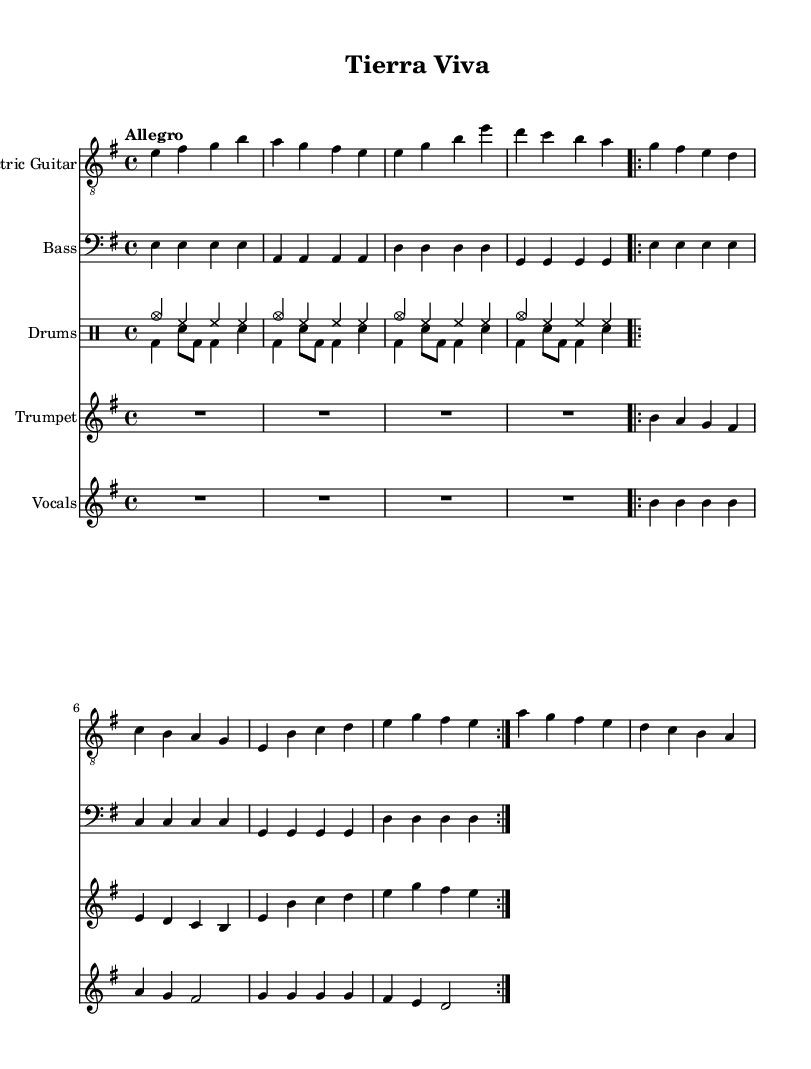What is the key signature of this music? The key signature is E minor, indicated by one sharp (F#) and pertains to the context of the piece. It can be identified at the beginning of the staff where it is stated, showing the notes that fall under E minor.
Answer: E minor What is the time signature used in the music? The time signature is 4/4, as indicated in the score near the beginning. This means there are four beats in each measure, and a quarter note receives one beat.
Answer: 4/4 What tempo marking is given in the piece? The tempo marking is "Allegro," which suggests a fast and lively tempo. This is directly noted at the top of the score and informs the performers about the intended speed of the piece.
Answer: Allegro How many measures does the electric guitar part have? The electric guitar part consists of 8 measures, which can be counted in the notation. Each group of notes separated by vertical lines represents a measure, totaling to eight when carefully counted.
Answer: 8 What instruments are featured in this composition? The composition features electric guitar, bass, drums, trumpet, and vocals. Each instrument has its own labeled staff in the score, making it clear which parts correspond to which instruments.
Answer: Electric guitar, bass, drums, trumpet, vocals How does the vocal melody primarily move through the piece? The vocal melody primarily consists of repetitive patterns and stepwise motion, as seen in the notes and their arrangements in the score. The specific structure and notes show that it generally stays close in range with a few leaps.
Answer: Repetitive patterns What is the theme of the lyrics in this piece? The lyrics convey a theme of environmental consciousness and urgency, as suggested by the lines referring to "tierra viva" and "protejamos." The words directly connect to the message of raising awareness for conservation.
Answer: Environmental consciousness 